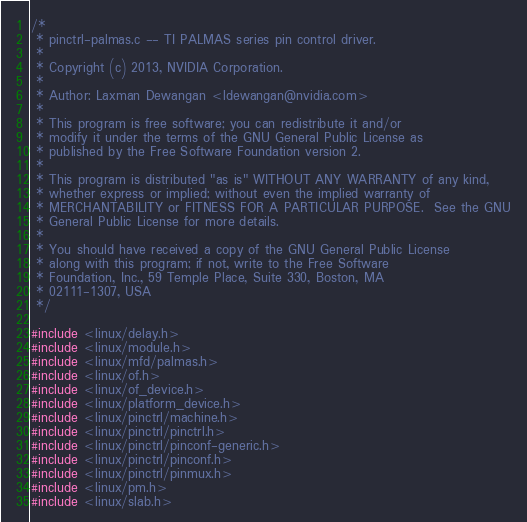<code> <loc_0><loc_0><loc_500><loc_500><_C_>/*
 * pinctrl-palmas.c -- TI PALMAS series pin control driver.
 *
 * Copyright (c) 2013, NVIDIA Corporation.
 *
 * Author: Laxman Dewangan <ldewangan@nvidia.com>
 *
 * This program is free software; you can redistribute it and/or
 * modify it under the terms of the GNU General Public License as
 * published by the Free Software Foundation version 2.
 *
 * This program is distributed "as is" WITHOUT ANY WARRANTY of any kind,
 * whether express or implied; without even the implied warranty of
 * MERCHANTABILITY or FITNESS FOR A PARTICULAR PURPOSE.  See the GNU
 * General Public License for more details.
 *
 * You should have received a copy of the GNU General Public License
 * along with this program; if not, write to the Free Software
 * Foundation, Inc., 59 Temple Place, Suite 330, Boston, MA
 * 02111-1307, USA
 */

#include <linux/delay.h>
#include <linux/module.h>
#include <linux/mfd/palmas.h>
#include <linux/of.h>
#include <linux/of_device.h>
#include <linux/platform_device.h>
#include <linux/pinctrl/machine.h>
#include <linux/pinctrl/pinctrl.h>
#include <linux/pinctrl/pinconf-generic.h>
#include <linux/pinctrl/pinconf.h>
#include <linux/pinctrl/pinmux.h>
#include <linux/pm.h>
#include <linux/slab.h>
</code> 